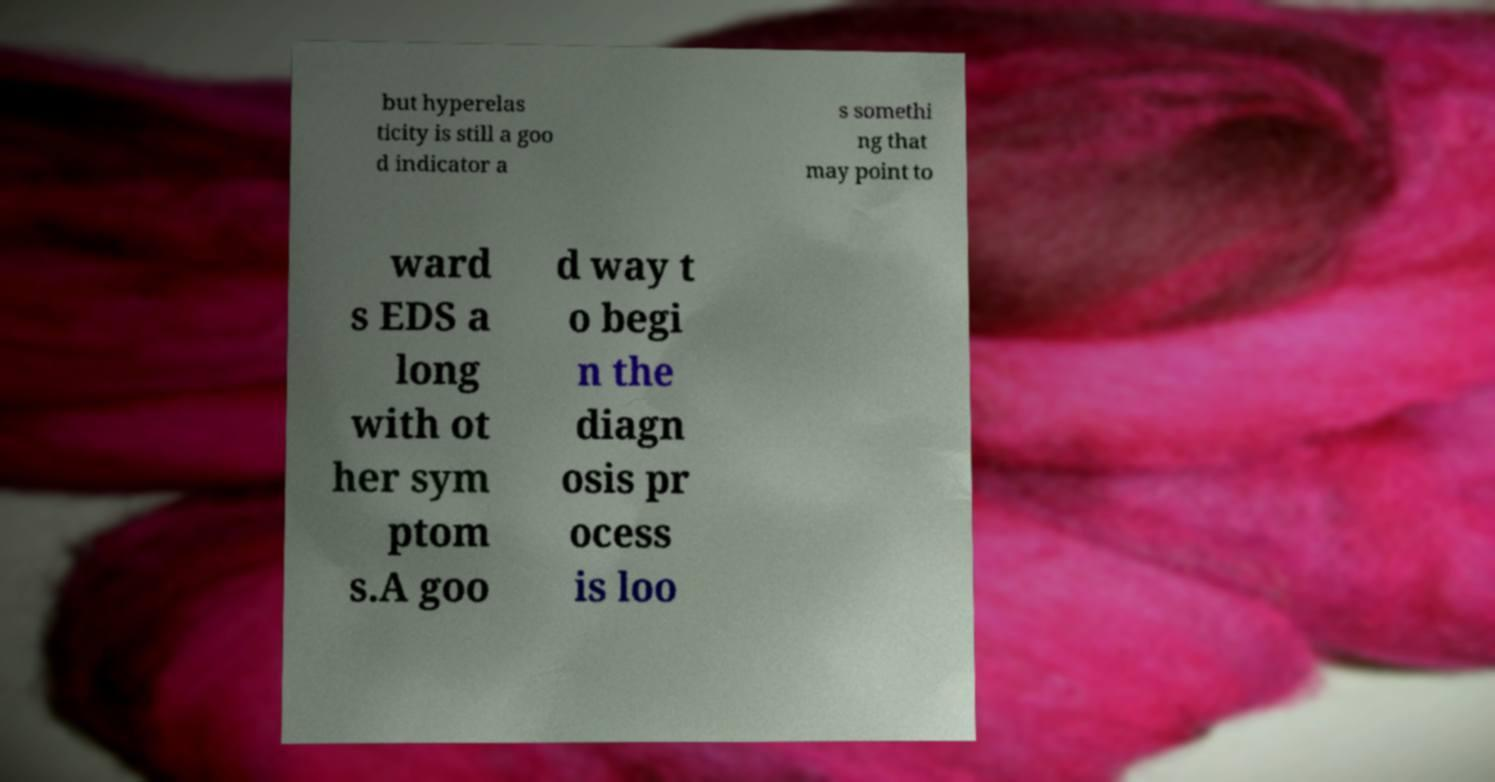Please read and relay the text visible in this image. What does it say? but hyperelas ticity is still a goo d indicator a s somethi ng that may point to ward s EDS a long with ot her sym ptom s.A goo d way t o begi n the diagn osis pr ocess is loo 